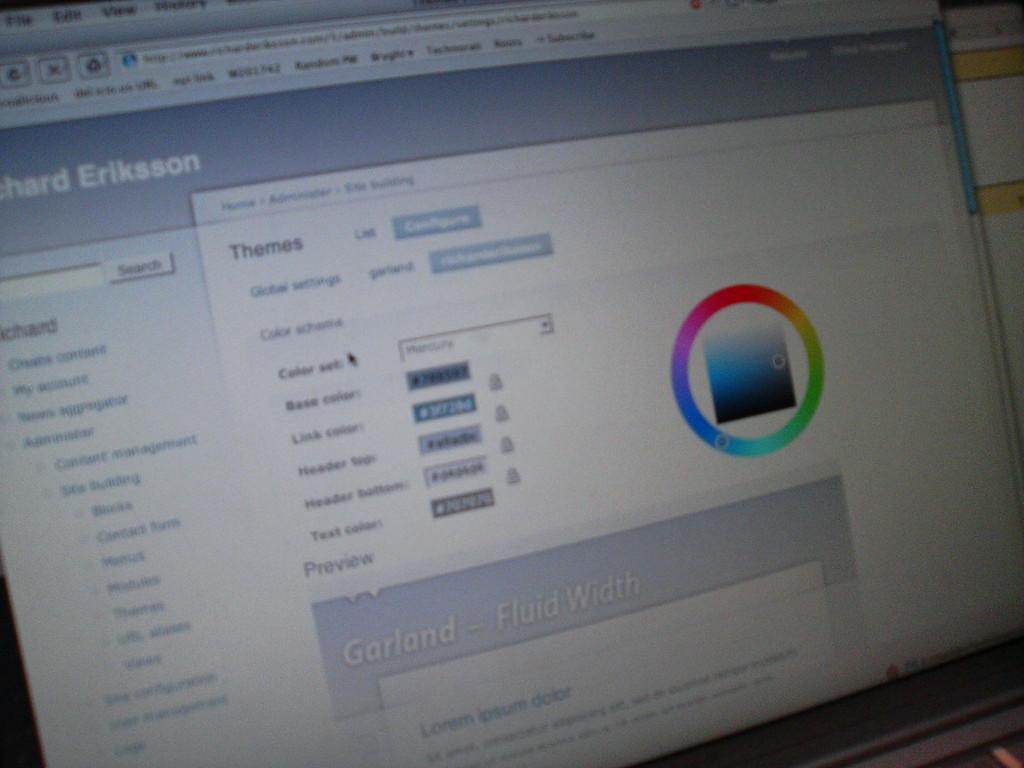<image>
Create a compact narrative representing the image presented. A computer is open to a website in which a customization page is open that is titled Themes. 